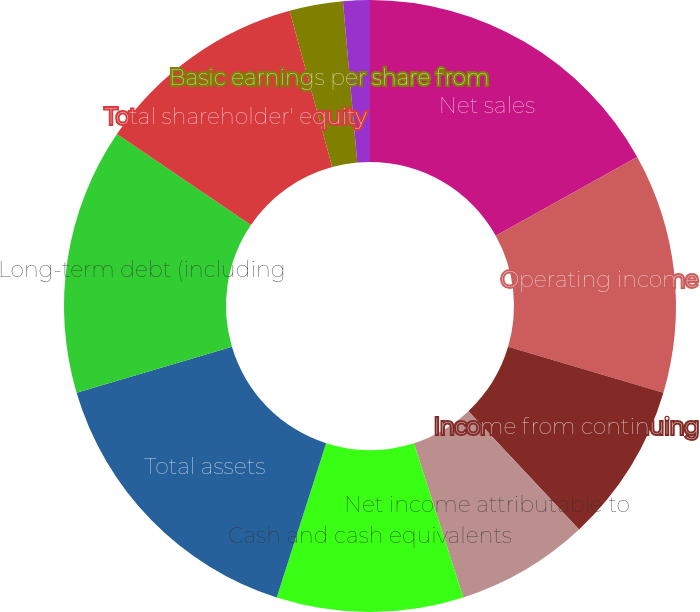<chart> <loc_0><loc_0><loc_500><loc_500><pie_chart><fcel>Net sales<fcel>Operating income<fcel>Income from continuing<fcel>Net income attributable to<fcel>Cash and cash equivalents<fcel>Total assets<fcel>Long-term debt (including<fcel>Total shareholder' equity<fcel>Basic earnings per share from<fcel>Diluted earnings per share<nl><fcel>16.9%<fcel>12.68%<fcel>8.45%<fcel>7.04%<fcel>9.86%<fcel>15.49%<fcel>14.08%<fcel>11.27%<fcel>2.82%<fcel>1.41%<nl></chart> 